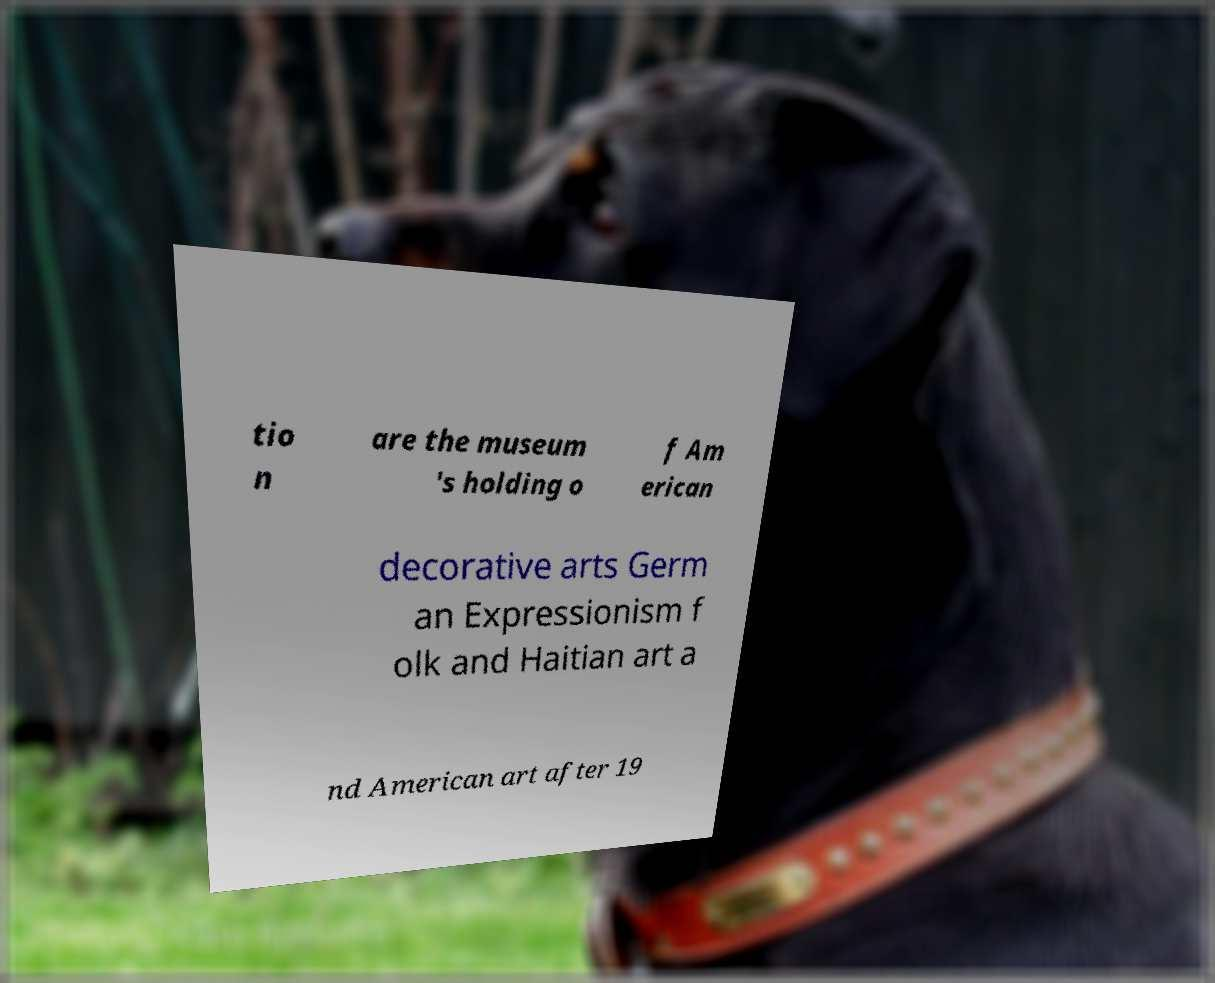Can you accurately transcribe the text from the provided image for me? tio n are the museum 's holding o f Am erican decorative arts Germ an Expressionism f olk and Haitian art a nd American art after 19 